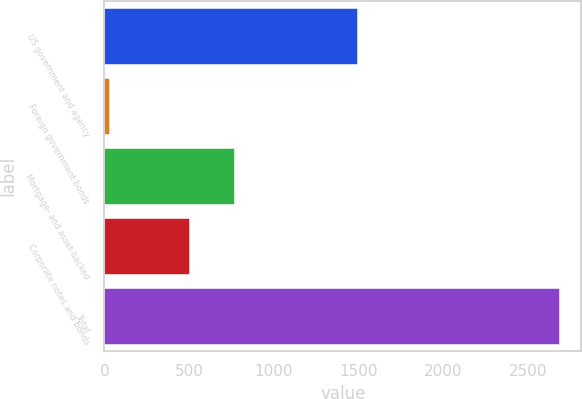<chart> <loc_0><loc_0><loc_500><loc_500><bar_chart><fcel>US government and agency<fcel>Foreign government bonds<fcel>Mortgage- and asset-backed<fcel>Corporate notes and bonds<fcel>Total<nl><fcel>1491<fcel>25<fcel>763.3<fcel>498<fcel>2678<nl></chart> 